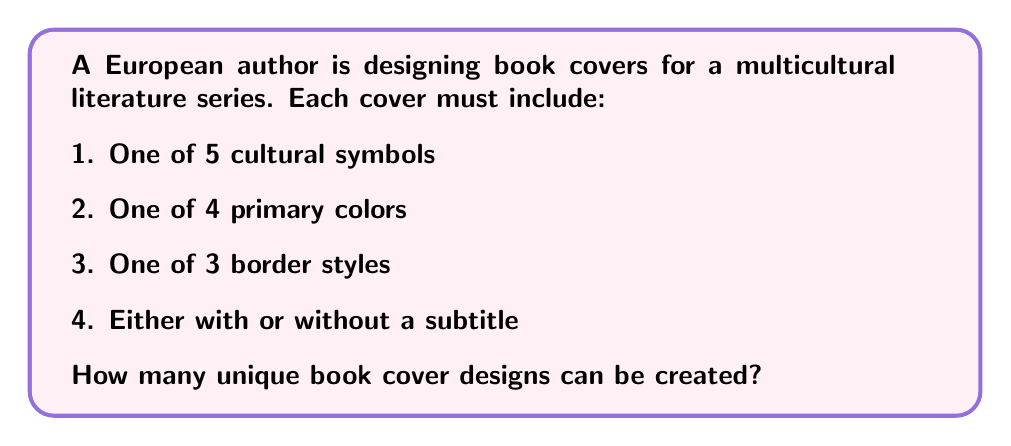Help me with this question. To solve this problem, we'll use the multiplication principle of counting. We'll multiply the number of choices for each element of the book cover design:

1. Cultural symbols: 5 choices
2. Primary colors: 4 choices
3. Border styles: 3 choices
4. Subtitle option: 2 choices (with or without)

The total number of unique combinations is:

$$ 5 \times 4 \times 3 \times 2 = 120 $$

Let's break it down step by step:

1. For each cultural symbol (5 choices), we have:
   - 4 color options
   - For each color, 3 border styles
   - For each border style, 2 subtitle options

2. We can represent this as a tree diagram, where each level represents a choice:

   $$ 5 \rightarrow 4 \rightarrow 3 \rightarrow 2 $$

3. The multiplication principle states that if we have a sequence of choices, where the number of choices for each decision is independent of the other choices, we multiply the number of possibilities for each choice.

4. Therefore, the total number of unique book cover designs is:

   $$ 5 \times 4 \times 3 \times 2 = 120 $$

This calculation ensures that every possible combination of cultural symbol, color, border style, and subtitle option is accounted for, providing a wide range of designs that reflect the multicultural nature of the literature series.
Answer: 120 unique designs 